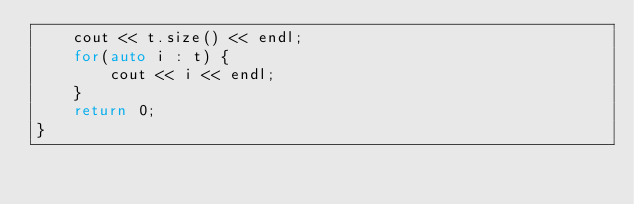Convert code to text. <code><loc_0><loc_0><loc_500><loc_500><_C++_>    cout << t.size() << endl;
    for(auto i : t) {
        cout << i << endl;
    }
    return 0;
}
</code> 